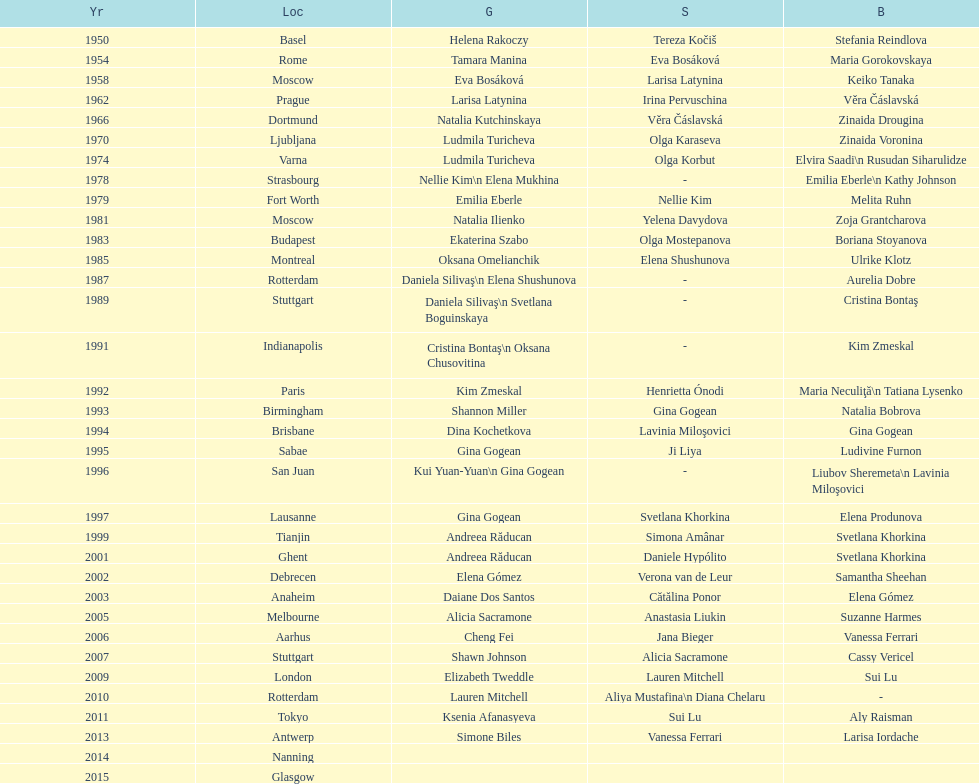Up to 2013, what is the count of gold medals in floor exercise achieved by american women at the world championships? 5. 